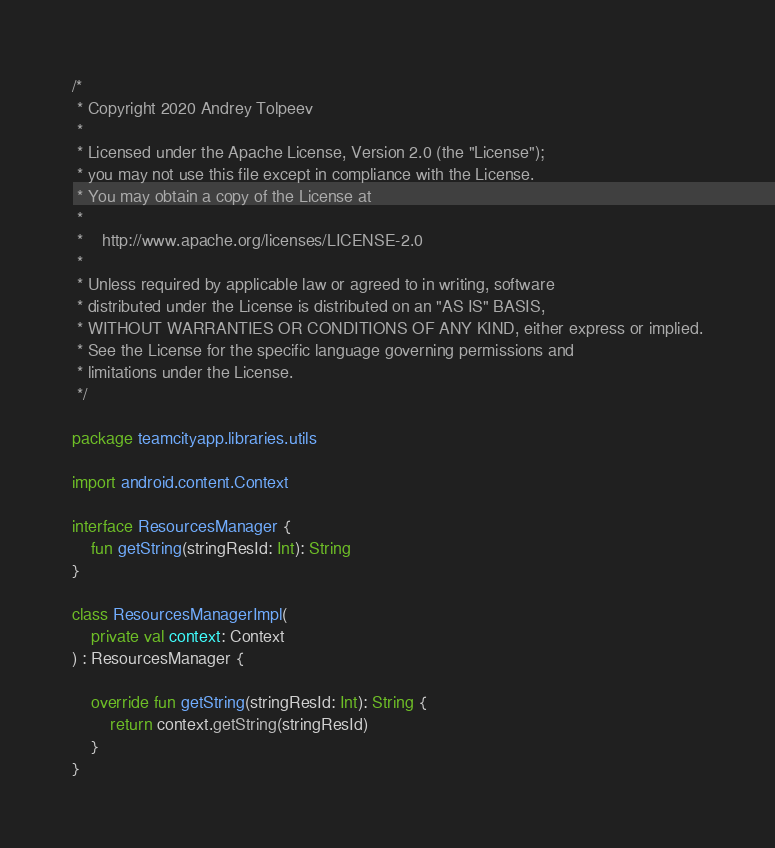Convert code to text. <code><loc_0><loc_0><loc_500><loc_500><_Kotlin_>/*
 * Copyright 2020 Andrey Tolpeev
 *
 * Licensed under the Apache License, Version 2.0 (the "License");
 * you may not use this file except in compliance with the License.
 * You may obtain a copy of the License at
 *
 *    http://www.apache.org/licenses/LICENSE-2.0
 *
 * Unless required by applicable law or agreed to in writing, software
 * distributed under the License is distributed on an "AS IS" BASIS,
 * WITHOUT WARRANTIES OR CONDITIONS OF ANY KIND, either express or implied.
 * See the License for the specific language governing permissions and
 * limitations under the License.
 */

package teamcityapp.libraries.utils

import android.content.Context

interface ResourcesManager {
    fun getString(stringResId: Int): String
}

class ResourcesManagerImpl(
    private val context: Context
) : ResourcesManager {

    override fun getString(stringResId: Int): String {
        return context.getString(stringResId)
    }
}
</code> 